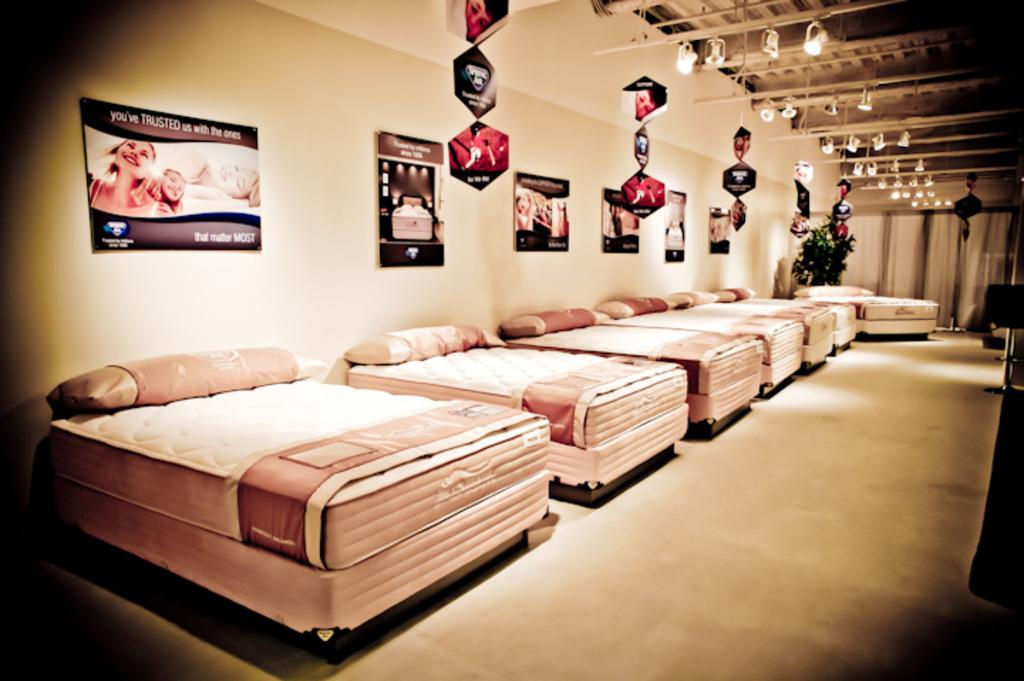What type of furniture is arranged in a line in the image? There are beds arranged in a line in the image. What accessories are present on each bed? Each bed has pillows and blankets. What can be seen on the walls in the image? There are posters on the walls. What is visible at the top of the image? There are hangings at the top of the image. What provides illumination in the image? There are lights visible in the image. Where is the mom sitting with the cows in the image? There is no mom or cows present in the image. What type of hydrant is visible in the image? There is no hydrant present in the image. 